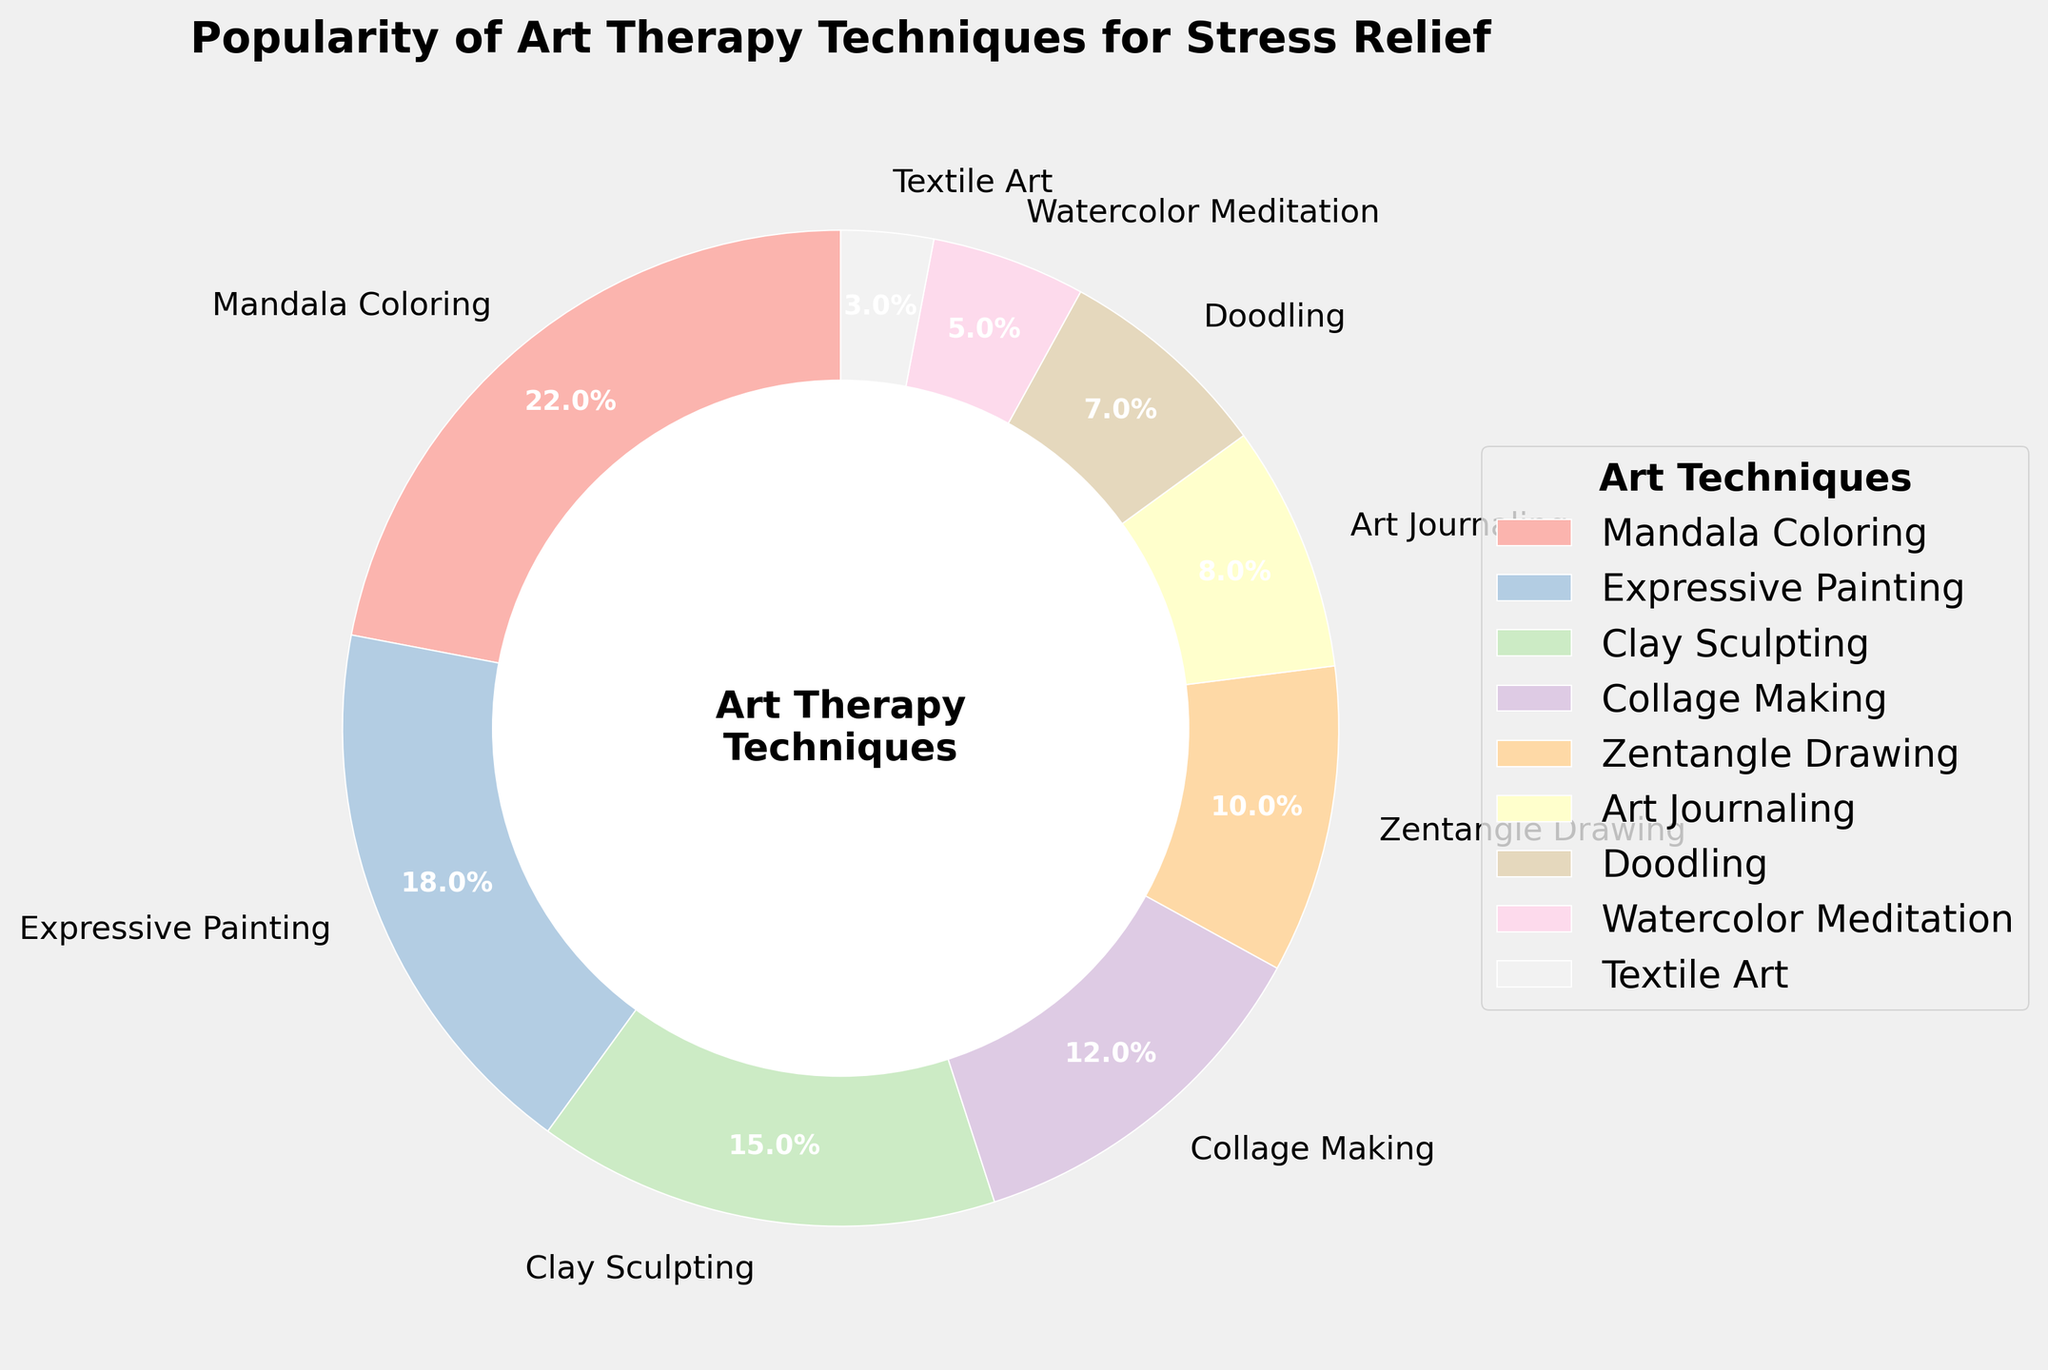Which art therapy technique is the most popular? The largest wedge in the pie chart represents the most popular technique. Based on the percentages, Mandala Coloring is the most popular since it has the largest portion at 22%.
Answer: Mandala Coloring Which two techniques are less popular than Zentangle Drawing? We need to identify techniques with percentages less than 10% (the percentage for Zentangle Drawing). Clay Sculpting has 15%, Doodling has 7%, Watercolor Meditation has 5%, and Textile Art has 3%. Doodling and Textile Art have less popularity than Zentangle Drawing.
Answer: Doodling and Textile Art What is the combined percentage of Expressive Painting and Collage Making? Add the percentages of Expressive Painting (18%) and Collage Making (12%). The total is 18% + 12% = 30%.
Answer: 30% Which technique is more popular: Art Journaling or Clay Sculpting? Compare the percentages for Art Journaling (8%) and Clay Sculpting (15%). Since 15% is greater than 8%, Clay Sculpting is more popular.
Answer: Clay Sculpting How much more popular is Mandala Coloring compared to Watercolor Meditation? Subtract the percentage of Watercolor Meditation (5%) from Mandala Coloring (22%). The difference is 22% - 5% = 17%.
Answer: 17% Rank the top three techniques in terms of popularity. Look at the highest percentages to determine the top three techniques: Mandala Coloring (22%), Expressive Painting (18%), and Clay Sculpting (15%).
Answer: Mandala Coloring, Expressive Painting, Clay Sculpting Which technique is less popular: Textile Art or Watercolor Meditation? Compare the percentages for Textile Art (3%) and Watercolor Meditation (5%). Since 3% is less than 5%, Textile Art is less popular.
Answer: Textile Art What is the total percentage of all techniques that have more than 10% popularity? Identify the techniques with more than 10%: Mandala Coloring (22%), Expressive Painting (18%), Clay Sculpting (15%), and Collage Making (12%). Add their percentages: 22% + 18% + 15% + 12% = 67%.
Answer: 67% What percentage of people prefer techniques other than Mandala Coloring, Expressive Painting, and Clay Sculpting? Subtract the combined percentage of Mandala Coloring (22%), Expressive Painting (18%), and Clay Sculpting (15%) from 100%. The sum is 22% + 18% + 15% = 55%, so 100% - 55% = 45%.
Answer: 45% 